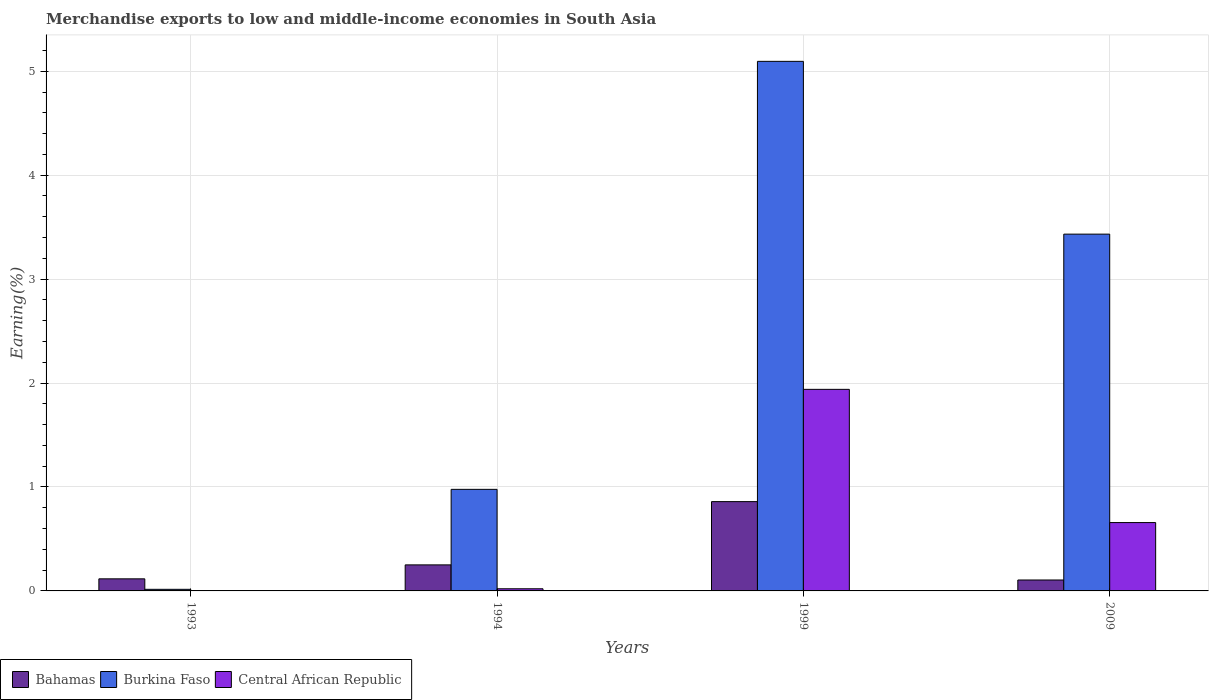How many bars are there on the 2nd tick from the right?
Make the answer very short. 3. What is the label of the 4th group of bars from the left?
Your answer should be compact. 2009. What is the percentage of amount earned from merchandise exports in Central African Republic in 1994?
Offer a very short reply. 0.02. Across all years, what is the maximum percentage of amount earned from merchandise exports in Bahamas?
Provide a succinct answer. 0.86. Across all years, what is the minimum percentage of amount earned from merchandise exports in Central African Republic?
Your answer should be compact. 0. What is the total percentage of amount earned from merchandise exports in Central African Republic in the graph?
Make the answer very short. 2.62. What is the difference between the percentage of amount earned from merchandise exports in Bahamas in 1993 and that in 2009?
Ensure brevity in your answer.  0.01. What is the difference between the percentage of amount earned from merchandise exports in Bahamas in 1999 and the percentage of amount earned from merchandise exports in Burkina Faso in 1994?
Ensure brevity in your answer.  -0.12. What is the average percentage of amount earned from merchandise exports in Burkina Faso per year?
Make the answer very short. 2.38. In the year 1994, what is the difference between the percentage of amount earned from merchandise exports in Bahamas and percentage of amount earned from merchandise exports in Central African Republic?
Make the answer very short. 0.23. In how many years, is the percentage of amount earned from merchandise exports in Burkina Faso greater than 3.8 %?
Ensure brevity in your answer.  1. What is the ratio of the percentage of amount earned from merchandise exports in Bahamas in 1994 to that in 1999?
Give a very brief answer. 0.29. Is the percentage of amount earned from merchandise exports in Central African Republic in 1999 less than that in 2009?
Make the answer very short. No. What is the difference between the highest and the second highest percentage of amount earned from merchandise exports in Burkina Faso?
Your response must be concise. 1.66. What is the difference between the highest and the lowest percentage of amount earned from merchandise exports in Central African Republic?
Your response must be concise. 1.94. Is the sum of the percentage of amount earned from merchandise exports in Burkina Faso in 1993 and 1994 greater than the maximum percentage of amount earned from merchandise exports in Bahamas across all years?
Offer a very short reply. Yes. What does the 2nd bar from the left in 1994 represents?
Offer a terse response. Burkina Faso. What does the 1st bar from the right in 2009 represents?
Offer a terse response. Central African Republic. Are all the bars in the graph horizontal?
Your answer should be compact. No. Are the values on the major ticks of Y-axis written in scientific E-notation?
Your answer should be very brief. No. Does the graph contain any zero values?
Provide a short and direct response. No. Does the graph contain grids?
Your answer should be compact. Yes. Where does the legend appear in the graph?
Your response must be concise. Bottom left. How many legend labels are there?
Offer a terse response. 3. What is the title of the graph?
Make the answer very short. Merchandise exports to low and middle-income economies in South Asia. Does "Spain" appear as one of the legend labels in the graph?
Your response must be concise. No. What is the label or title of the Y-axis?
Give a very brief answer. Earning(%). What is the Earning(%) of Bahamas in 1993?
Provide a short and direct response. 0.12. What is the Earning(%) in Burkina Faso in 1993?
Your answer should be compact. 0.02. What is the Earning(%) in Central African Republic in 1993?
Provide a succinct answer. 0. What is the Earning(%) of Bahamas in 1994?
Provide a short and direct response. 0.25. What is the Earning(%) in Burkina Faso in 1994?
Your answer should be very brief. 0.98. What is the Earning(%) of Central African Republic in 1994?
Offer a terse response. 0.02. What is the Earning(%) in Bahamas in 1999?
Your answer should be compact. 0.86. What is the Earning(%) of Burkina Faso in 1999?
Provide a short and direct response. 5.1. What is the Earning(%) of Central African Republic in 1999?
Your response must be concise. 1.94. What is the Earning(%) of Bahamas in 2009?
Provide a succinct answer. 0.11. What is the Earning(%) of Burkina Faso in 2009?
Your response must be concise. 3.43. What is the Earning(%) in Central African Republic in 2009?
Keep it short and to the point. 0.66. Across all years, what is the maximum Earning(%) in Bahamas?
Your answer should be compact. 0.86. Across all years, what is the maximum Earning(%) in Burkina Faso?
Keep it short and to the point. 5.1. Across all years, what is the maximum Earning(%) of Central African Republic?
Offer a terse response. 1.94. Across all years, what is the minimum Earning(%) of Bahamas?
Your answer should be compact. 0.11. Across all years, what is the minimum Earning(%) in Burkina Faso?
Keep it short and to the point. 0.02. Across all years, what is the minimum Earning(%) in Central African Republic?
Offer a terse response. 0. What is the total Earning(%) in Bahamas in the graph?
Your response must be concise. 1.33. What is the total Earning(%) of Burkina Faso in the graph?
Keep it short and to the point. 9.52. What is the total Earning(%) in Central African Republic in the graph?
Give a very brief answer. 2.62. What is the difference between the Earning(%) in Bahamas in 1993 and that in 1994?
Provide a short and direct response. -0.13. What is the difference between the Earning(%) in Burkina Faso in 1993 and that in 1994?
Your answer should be compact. -0.96. What is the difference between the Earning(%) of Central African Republic in 1993 and that in 1994?
Give a very brief answer. -0.02. What is the difference between the Earning(%) of Bahamas in 1993 and that in 1999?
Keep it short and to the point. -0.74. What is the difference between the Earning(%) of Burkina Faso in 1993 and that in 1999?
Provide a short and direct response. -5.08. What is the difference between the Earning(%) of Central African Republic in 1993 and that in 1999?
Give a very brief answer. -1.94. What is the difference between the Earning(%) of Bahamas in 1993 and that in 2009?
Your response must be concise. 0.01. What is the difference between the Earning(%) in Burkina Faso in 1993 and that in 2009?
Make the answer very short. -3.42. What is the difference between the Earning(%) in Central African Republic in 1993 and that in 2009?
Offer a terse response. -0.66. What is the difference between the Earning(%) of Bahamas in 1994 and that in 1999?
Offer a terse response. -0.61. What is the difference between the Earning(%) in Burkina Faso in 1994 and that in 1999?
Offer a terse response. -4.12. What is the difference between the Earning(%) in Central African Republic in 1994 and that in 1999?
Provide a short and direct response. -1.92. What is the difference between the Earning(%) in Bahamas in 1994 and that in 2009?
Provide a short and direct response. 0.15. What is the difference between the Earning(%) in Burkina Faso in 1994 and that in 2009?
Ensure brevity in your answer.  -2.46. What is the difference between the Earning(%) in Central African Republic in 1994 and that in 2009?
Your answer should be very brief. -0.64. What is the difference between the Earning(%) in Bahamas in 1999 and that in 2009?
Give a very brief answer. 0.75. What is the difference between the Earning(%) in Burkina Faso in 1999 and that in 2009?
Provide a short and direct response. 1.66. What is the difference between the Earning(%) of Central African Republic in 1999 and that in 2009?
Give a very brief answer. 1.28. What is the difference between the Earning(%) in Bahamas in 1993 and the Earning(%) in Burkina Faso in 1994?
Your response must be concise. -0.86. What is the difference between the Earning(%) of Bahamas in 1993 and the Earning(%) of Central African Republic in 1994?
Your response must be concise. 0.1. What is the difference between the Earning(%) of Burkina Faso in 1993 and the Earning(%) of Central African Republic in 1994?
Ensure brevity in your answer.  -0.01. What is the difference between the Earning(%) in Bahamas in 1993 and the Earning(%) in Burkina Faso in 1999?
Keep it short and to the point. -4.98. What is the difference between the Earning(%) in Bahamas in 1993 and the Earning(%) in Central African Republic in 1999?
Your answer should be compact. -1.82. What is the difference between the Earning(%) in Burkina Faso in 1993 and the Earning(%) in Central African Republic in 1999?
Your answer should be compact. -1.92. What is the difference between the Earning(%) of Bahamas in 1993 and the Earning(%) of Burkina Faso in 2009?
Your response must be concise. -3.32. What is the difference between the Earning(%) of Bahamas in 1993 and the Earning(%) of Central African Republic in 2009?
Offer a terse response. -0.54. What is the difference between the Earning(%) in Burkina Faso in 1993 and the Earning(%) in Central African Republic in 2009?
Provide a succinct answer. -0.64. What is the difference between the Earning(%) in Bahamas in 1994 and the Earning(%) in Burkina Faso in 1999?
Give a very brief answer. -4.84. What is the difference between the Earning(%) of Bahamas in 1994 and the Earning(%) of Central African Republic in 1999?
Your response must be concise. -1.69. What is the difference between the Earning(%) in Burkina Faso in 1994 and the Earning(%) in Central African Republic in 1999?
Keep it short and to the point. -0.96. What is the difference between the Earning(%) of Bahamas in 1994 and the Earning(%) of Burkina Faso in 2009?
Make the answer very short. -3.18. What is the difference between the Earning(%) in Bahamas in 1994 and the Earning(%) in Central African Republic in 2009?
Offer a very short reply. -0.41. What is the difference between the Earning(%) in Burkina Faso in 1994 and the Earning(%) in Central African Republic in 2009?
Your response must be concise. 0.32. What is the difference between the Earning(%) in Bahamas in 1999 and the Earning(%) in Burkina Faso in 2009?
Your answer should be very brief. -2.57. What is the difference between the Earning(%) in Bahamas in 1999 and the Earning(%) in Central African Republic in 2009?
Your answer should be very brief. 0.2. What is the difference between the Earning(%) of Burkina Faso in 1999 and the Earning(%) of Central African Republic in 2009?
Make the answer very short. 4.44. What is the average Earning(%) in Bahamas per year?
Give a very brief answer. 0.33. What is the average Earning(%) in Burkina Faso per year?
Provide a short and direct response. 2.38. What is the average Earning(%) of Central African Republic per year?
Your answer should be compact. 0.65. In the year 1993, what is the difference between the Earning(%) of Bahamas and Earning(%) of Burkina Faso?
Offer a very short reply. 0.1. In the year 1993, what is the difference between the Earning(%) in Bahamas and Earning(%) in Central African Republic?
Your answer should be very brief. 0.12. In the year 1993, what is the difference between the Earning(%) in Burkina Faso and Earning(%) in Central African Republic?
Give a very brief answer. 0.01. In the year 1994, what is the difference between the Earning(%) of Bahamas and Earning(%) of Burkina Faso?
Ensure brevity in your answer.  -0.73. In the year 1994, what is the difference between the Earning(%) in Bahamas and Earning(%) in Central African Republic?
Keep it short and to the point. 0.23. In the year 1994, what is the difference between the Earning(%) of Burkina Faso and Earning(%) of Central African Republic?
Make the answer very short. 0.96. In the year 1999, what is the difference between the Earning(%) of Bahamas and Earning(%) of Burkina Faso?
Give a very brief answer. -4.24. In the year 1999, what is the difference between the Earning(%) in Bahamas and Earning(%) in Central African Republic?
Ensure brevity in your answer.  -1.08. In the year 1999, what is the difference between the Earning(%) of Burkina Faso and Earning(%) of Central African Republic?
Provide a succinct answer. 3.16. In the year 2009, what is the difference between the Earning(%) in Bahamas and Earning(%) in Burkina Faso?
Make the answer very short. -3.33. In the year 2009, what is the difference between the Earning(%) of Bahamas and Earning(%) of Central African Republic?
Your answer should be very brief. -0.55. In the year 2009, what is the difference between the Earning(%) of Burkina Faso and Earning(%) of Central African Republic?
Make the answer very short. 2.78. What is the ratio of the Earning(%) of Bahamas in 1993 to that in 1994?
Give a very brief answer. 0.46. What is the ratio of the Earning(%) in Burkina Faso in 1993 to that in 1994?
Provide a succinct answer. 0.02. What is the ratio of the Earning(%) in Central African Republic in 1993 to that in 1994?
Offer a very short reply. 0.06. What is the ratio of the Earning(%) of Bahamas in 1993 to that in 1999?
Provide a short and direct response. 0.14. What is the ratio of the Earning(%) in Burkina Faso in 1993 to that in 1999?
Make the answer very short. 0. What is the ratio of the Earning(%) of Central African Republic in 1993 to that in 1999?
Keep it short and to the point. 0. What is the ratio of the Earning(%) in Bahamas in 1993 to that in 2009?
Offer a terse response. 1.11. What is the ratio of the Earning(%) of Burkina Faso in 1993 to that in 2009?
Keep it short and to the point. 0. What is the ratio of the Earning(%) in Central African Republic in 1993 to that in 2009?
Offer a very short reply. 0. What is the ratio of the Earning(%) in Bahamas in 1994 to that in 1999?
Give a very brief answer. 0.29. What is the ratio of the Earning(%) of Burkina Faso in 1994 to that in 1999?
Your answer should be compact. 0.19. What is the ratio of the Earning(%) in Central African Republic in 1994 to that in 1999?
Give a very brief answer. 0.01. What is the ratio of the Earning(%) of Bahamas in 1994 to that in 2009?
Keep it short and to the point. 2.38. What is the ratio of the Earning(%) in Burkina Faso in 1994 to that in 2009?
Your answer should be compact. 0.28. What is the ratio of the Earning(%) of Central African Republic in 1994 to that in 2009?
Offer a very short reply. 0.03. What is the ratio of the Earning(%) in Bahamas in 1999 to that in 2009?
Make the answer very short. 8.17. What is the ratio of the Earning(%) of Burkina Faso in 1999 to that in 2009?
Your answer should be compact. 1.48. What is the ratio of the Earning(%) of Central African Republic in 1999 to that in 2009?
Keep it short and to the point. 2.95. What is the difference between the highest and the second highest Earning(%) in Bahamas?
Keep it short and to the point. 0.61. What is the difference between the highest and the second highest Earning(%) of Burkina Faso?
Your answer should be very brief. 1.66. What is the difference between the highest and the second highest Earning(%) in Central African Republic?
Offer a very short reply. 1.28. What is the difference between the highest and the lowest Earning(%) of Bahamas?
Your answer should be very brief. 0.75. What is the difference between the highest and the lowest Earning(%) of Burkina Faso?
Provide a short and direct response. 5.08. What is the difference between the highest and the lowest Earning(%) of Central African Republic?
Your answer should be compact. 1.94. 